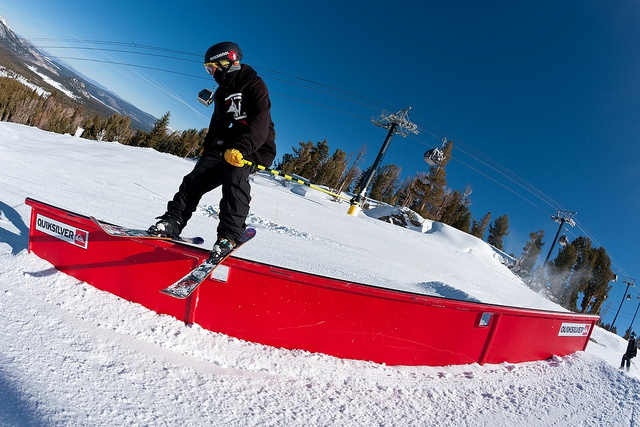Describe the objects in this image and their specific colors. I can see people in lightblue, black, gray, darkgray, and lightgray tones, skis in lightblue, gray, darkgray, black, and lightgray tones, and skis in lightblue, lightgray, darkgray, and gray tones in this image. 